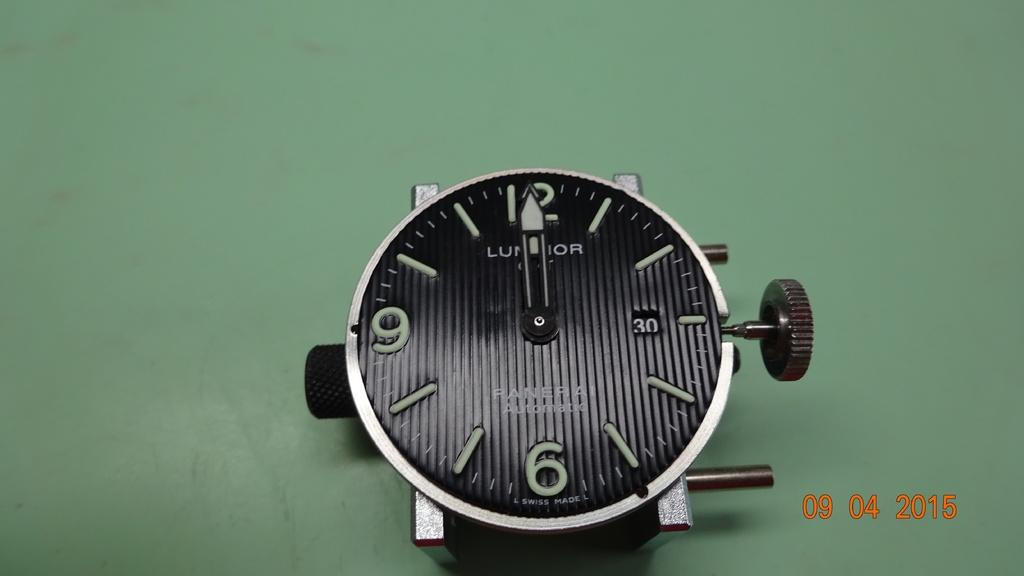<image>
Share a concise interpretation of the image provided. The black watch is from the brand Luminor 